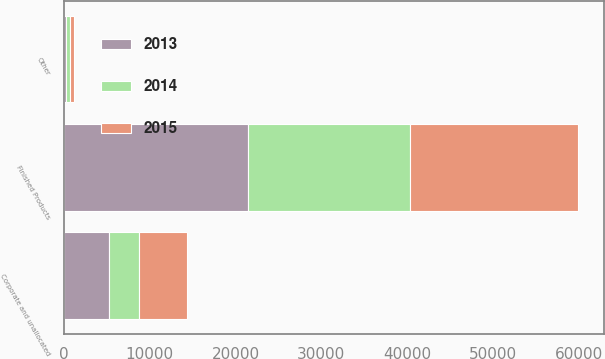<chart> <loc_0><loc_0><loc_500><loc_500><stacked_bar_chart><ecel><fcel>Finished Products<fcel>Other<fcel>Corporate and unallocated<nl><fcel>2013<fcel>21464<fcel>231<fcel>5297<nl><fcel>2015<fcel>19572<fcel>531<fcel>5548<nl><fcel>2014<fcel>18888<fcel>423<fcel>3451<nl></chart> 